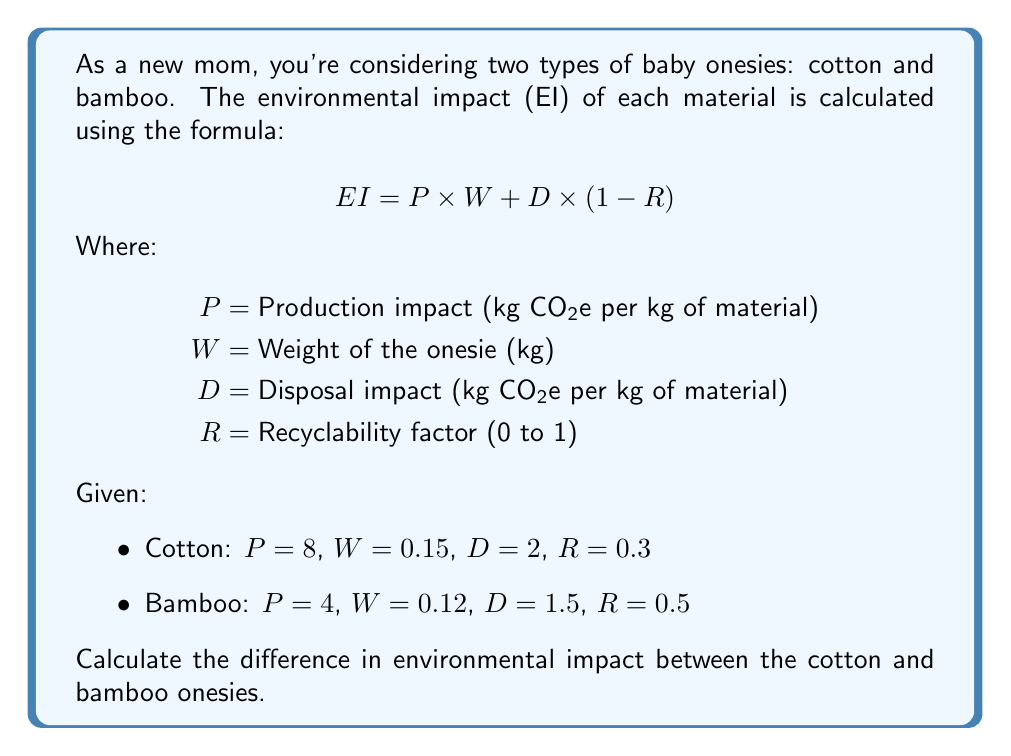Show me your answer to this math problem. Let's calculate the environmental impact for each material step-by-step:

1. Cotton onesie:
   $$ EI_{cotton} = P \times W + D \times (1-R) $$
   $$ EI_{cotton} = 8 \times 0.15 + 2 \times (1-0.3) $$
   $$ EI_{cotton} = 1.2 + 2 \times 0.7 $$
   $$ EI_{cotton} = 1.2 + 1.4 = 2.6 \text{ kg CO₂e} $$

2. Bamboo onesie:
   $$ EI_{bamboo} = P \times W + D \times (1-R) $$
   $$ EI_{bamboo} = 4 \times 0.12 + 1.5 \times (1-0.5) $$
   $$ EI_{bamboo} = 0.48 + 1.5 \times 0.5 $$
   $$ EI_{bamboo} = 0.48 + 0.75 = 1.23 \text{ kg CO₂e} $$

3. Calculate the difference:
   $$ \text{Difference} = EI_{cotton} - EI_{bamboo} $$
   $$ \text{Difference} = 2.6 - 1.23 = 1.37 \text{ kg CO₂e} $$
Answer: 1.37 kg CO₂e 